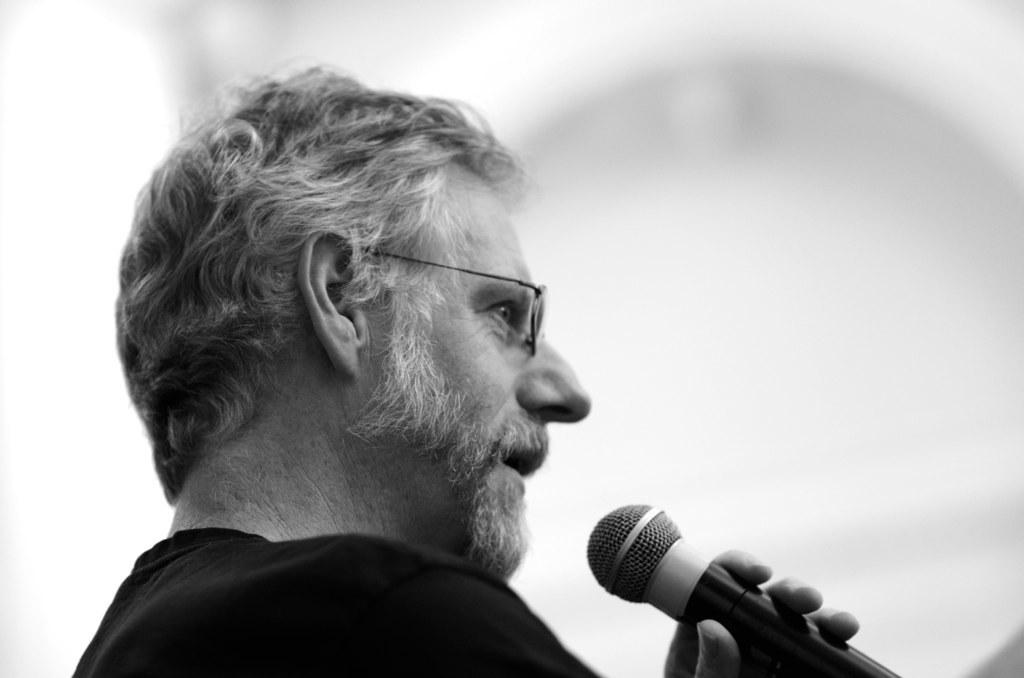What is the color scheme of the image? The image is black and white. Can you describe the person in the image? There is a person in the image, and they are holding a microphone. What can be seen in the background of the image? The background of the image is white. What type of club is the person using to hit the hook in the image? There is no club or hook present in the image; it features a person holding a microphone against a white background. 